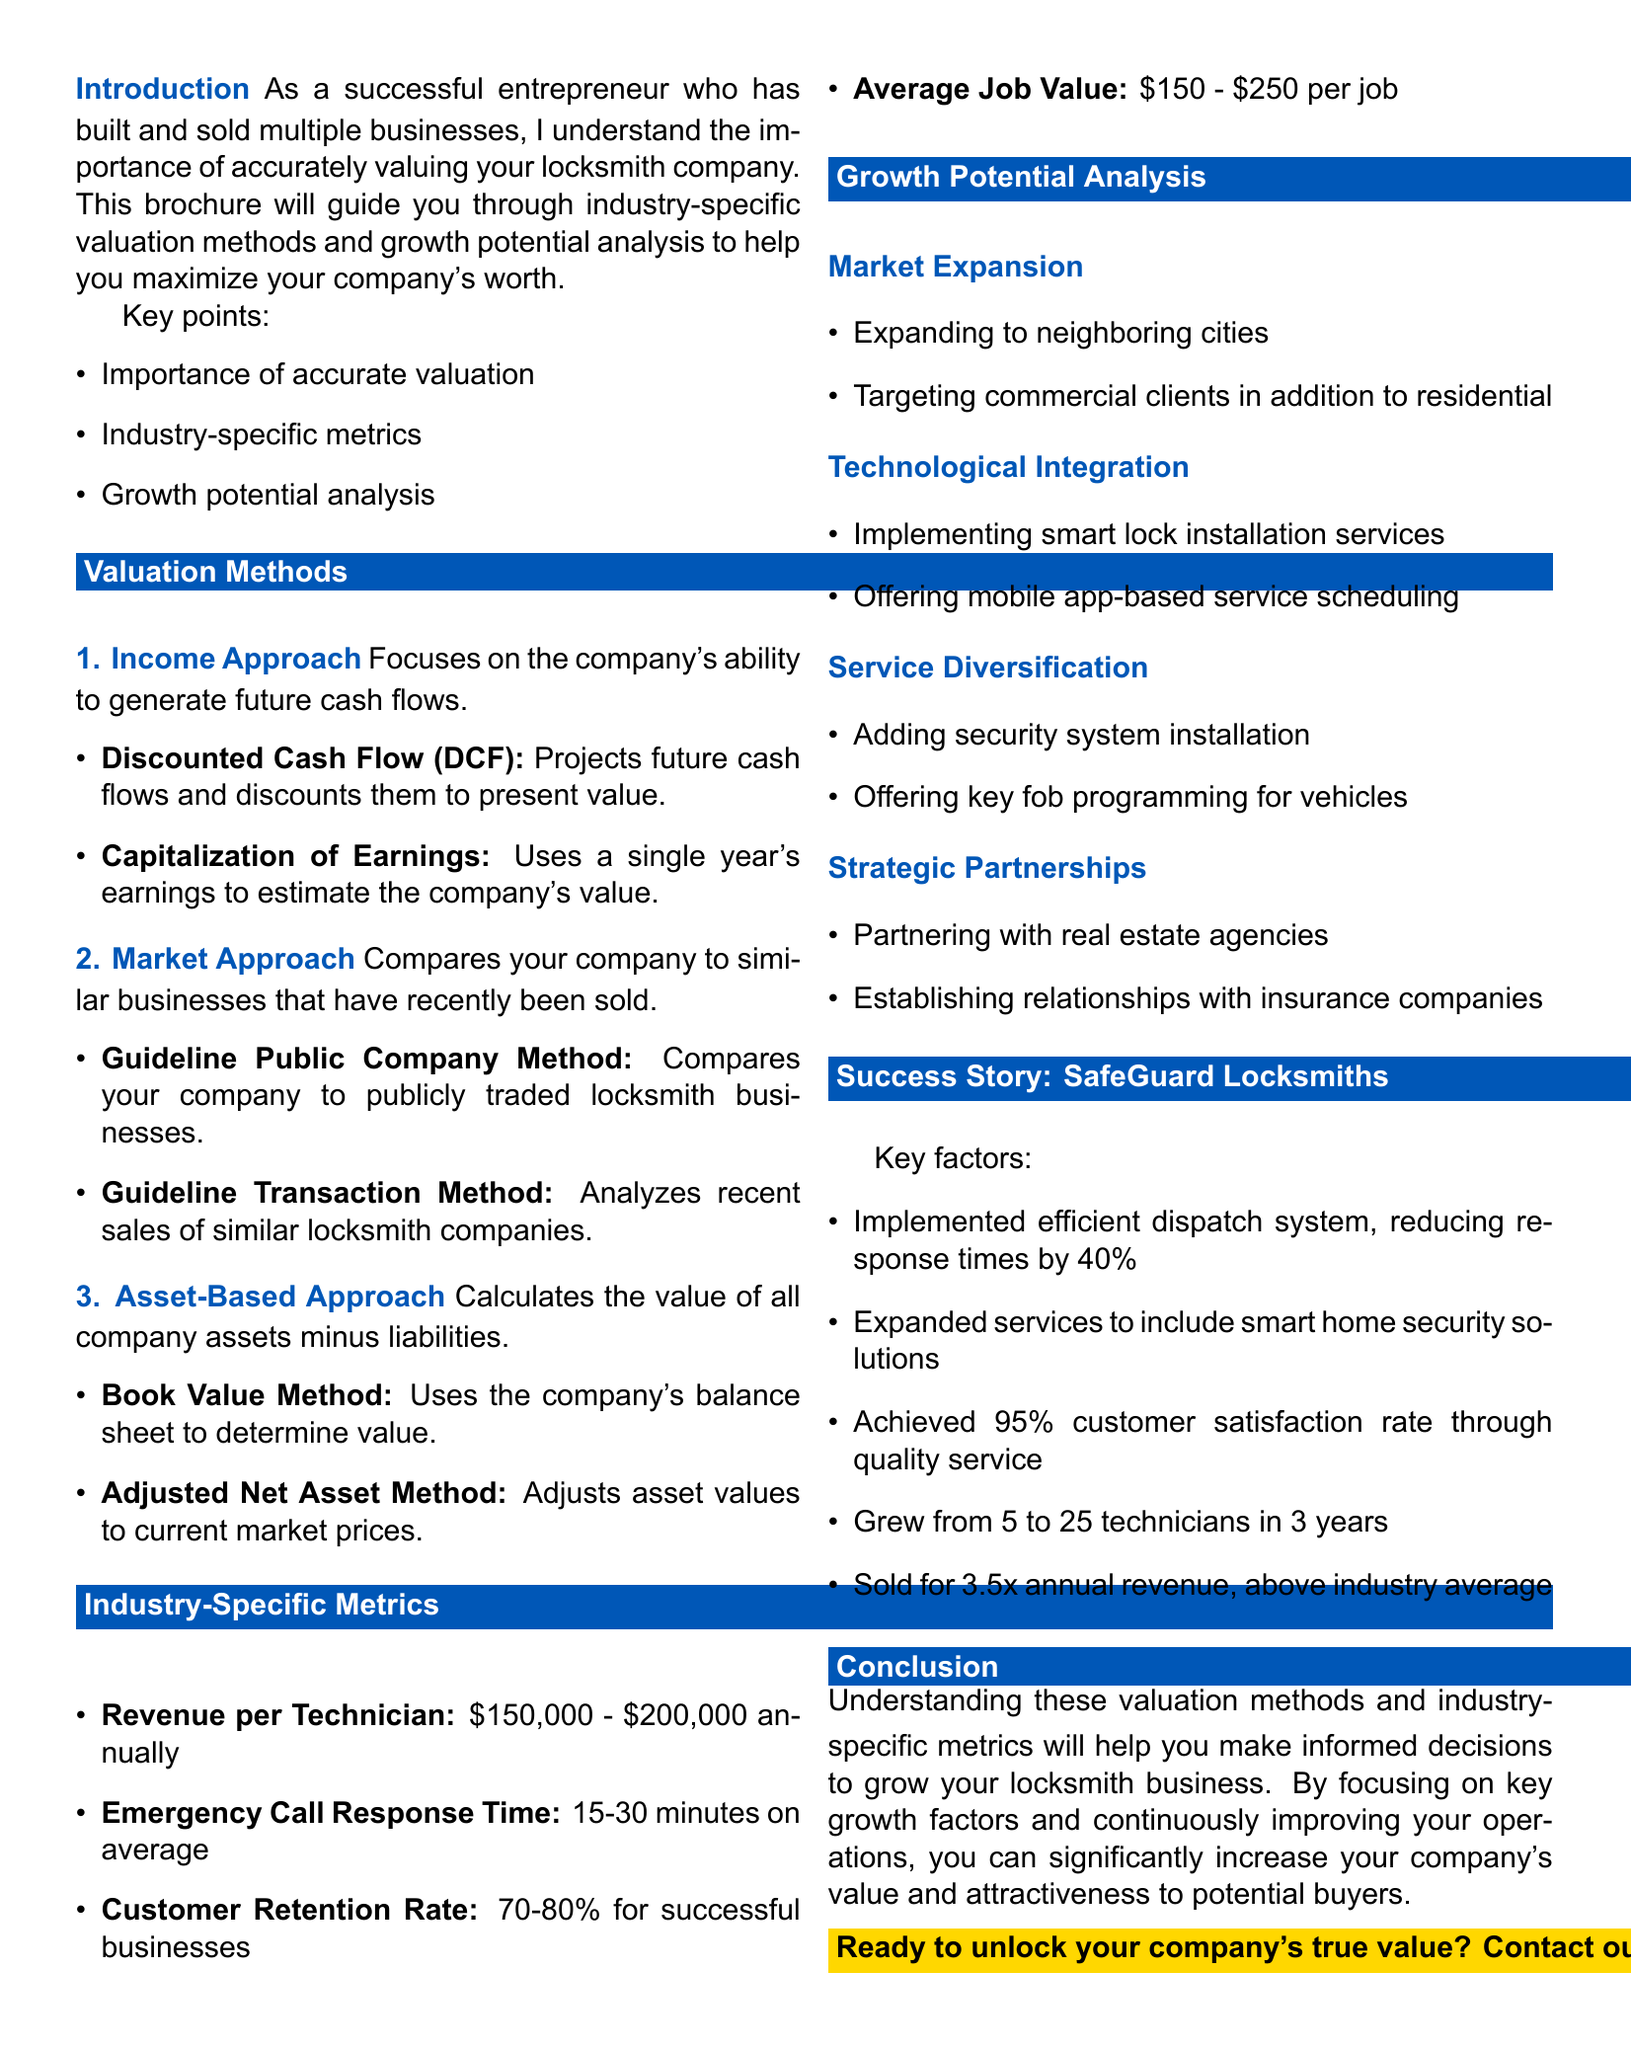What is the title of the brochure? The title of the brochure is the first element presented at the top of the document.
Answer: Unlocking Value: Business Valuation Methods for Locksmith Companies What are the two sub-methods under the Income Approach? The sub-methods are listed under the Income Approach section.
Answer: Discounted Cash Flow (DCF), Capitalization of Earnings What is the benchmark for Revenue per Technician? The benchmark is provided as a specific range under industry-specific metrics.
Answer: $150,000 - $200,000 per technician annually What percentage reflects a successful Customer Retention Rate? The percentage is stated in the document as a standard for successful businesses.
Answer: 70-80% How much did SafeGuard Locksmiths sell for relative to annual revenue? This is specified in the success story of the case study section.
Answer: 3.5x annual revenue What is one example of Service Diversification mentioned? An example is provided in the growth potential analysis section.
Answer: Adding security system installation What does Technological Integration involve? This is explained in the growth potential analysis section.
Answer: Adoption of advanced locksmith technologies What is the average response time for emergency calls? This information is detailed in the industry-specific metrics section.
Answer: 15-30 minutes on average What key factor contributed to SafeGuard Locksmiths' success? Several factors are listed; one is highlighted in the case study.
Answer: Implemented efficient dispatch system, reducing response times by 40% 